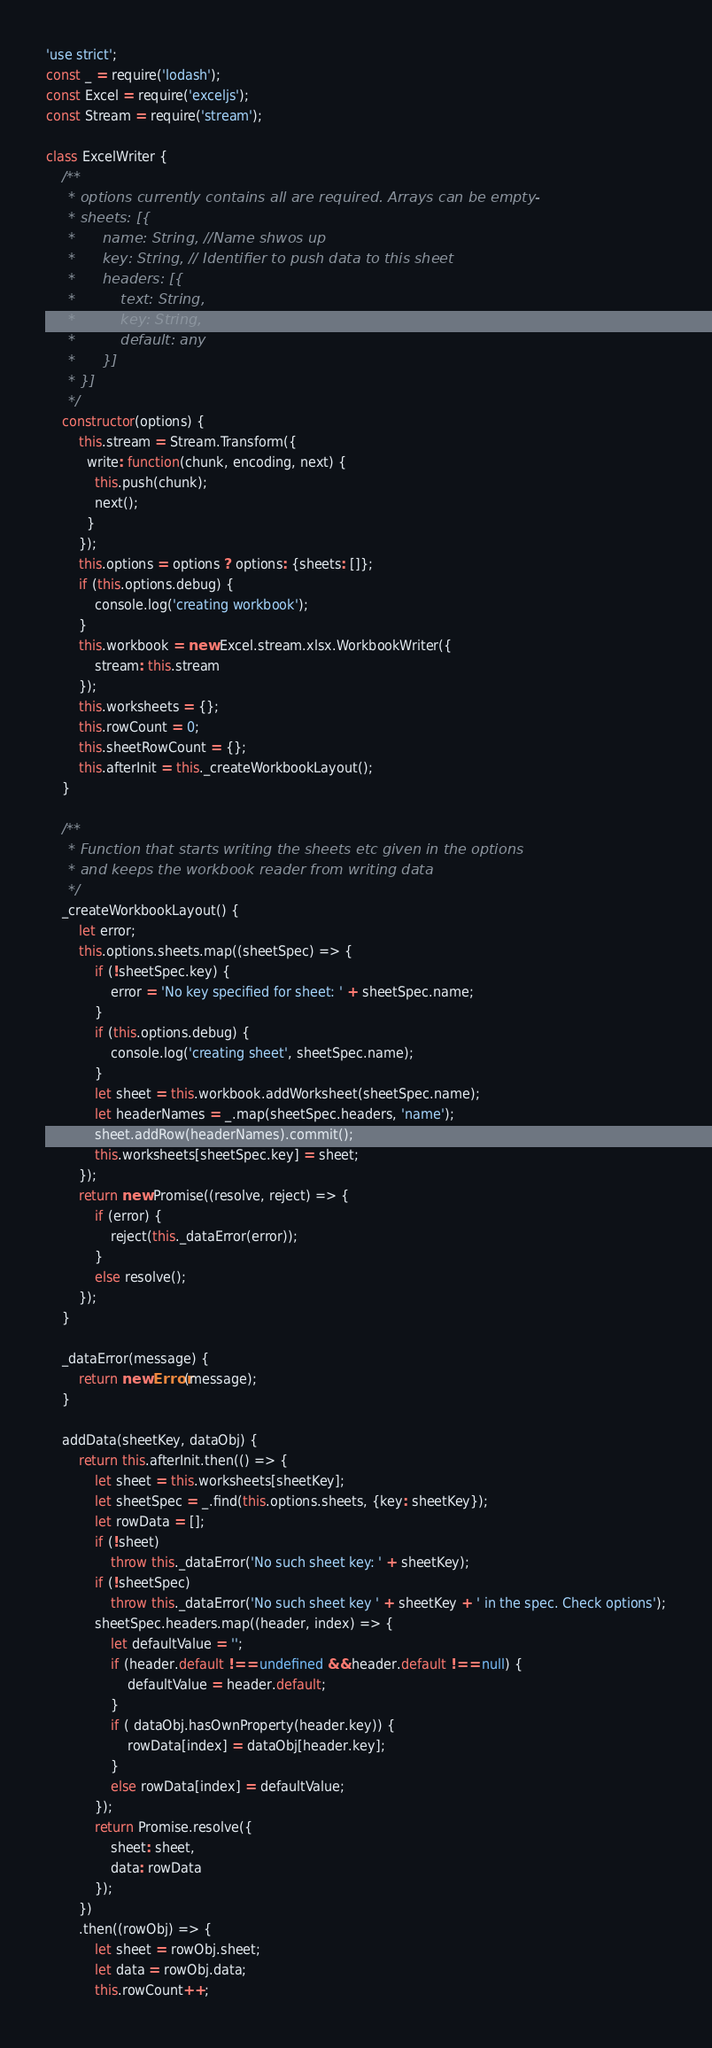<code> <loc_0><loc_0><loc_500><loc_500><_JavaScript_>'use strict';
const _ = require('lodash');
const Excel = require('exceljs');
const Stream = require('stream');

class ExcelWriter {
	/**
	 * options currently contains all are required. Arrays can be empty-
	 * sheets: [{
	 *		name: String, //Name shwos up
	 *		key: String, // Identifier to push data to this sheet
	 *		headers: [{
	 *			text: String,
	 *			key: String,
	 *			default: any
	 *		}]
	 * }]
	 */
	constructor(options) {
		this.stream = Stream.Transform({
		  write: function(chunk, encoding, next) {
			this.push(chunk);
			next();
		  }
		});
		this.options = options ? options: {sheets: []};
		if (this.options.debug) {
			console.log('creating workbook');
		}
		this.workbook = new Excel.stream.xlsx.WorkbookWriter({
			stream: this.stream
		});
		this.worksheets = {};
		this.rowCount = 0;
		this.sheetRowCount = {};
		this.afterInit = this._createWorkbookLayout();
	}

	/**
	 * Function that starts writing the sheets etc given in the options
	 * and keeps the workbook reader from writing data
	 */
	_createWorkbookLayout() {
        let error;
		this.options.sheets.map((sheetSpec) => {
            if (!sheetSpec.key) {
                error = 'No key specified for sheet: ' + sheetSpec.name;
            }
			if (this.options.debug) {
				console.log('creating sheet', sheetSpec.name);
			}
			let sheet = this.workbook.addWorksheet(sheetSpec.name);
			let headerNames = _.map(sheetSpec.headers, 'name');
			sheet.addRow(headerNames).commit();
			this.worksheets[sheetSpec.key] = sheet;
		});
		return new Promise((resolve, reject) => {
            if (error) {
                reject(this._dataError(error));
            }
            else resolve();
        });
	}

    _dataError(message) {
        return new Error(message);
    }

	addData(sheetKey, dataObj) {
		return this.afterInit.then(() => {
			let sheet = this.worksheets[sheetKey];
			let sheetSpec = _.find(this.options.sheets, {key: sheetKey});
			let rowData = [];
			if (!sheet)
				throw this._dataError('No such sheet key: ' + sheetKey);
			if (!sheetSpec)
				throw this._dataError('No such sheet key ' + sheetKey + ' in the spec. Check options');
			sheetSpec.headers.map((header, index) => {
				let defaultValue = '';
				if (header.default !== undefined && header.default !== null) {
					defaultValue = header.default;
				}
				if ( dataObj.hasOwnProperty(header.key)) {
					rowData[index] = dataObj[header.key];
				}
				else rowData[index] = defaultValue;
			});
			return Promise.resolve({
				sheet: sheet,
				data: rowData
			});
		})
		.then((rowObj) => {
			let sheet = rowObj.sheet;
			let data = rowObj.data;
			this.rowCount++;</code> 